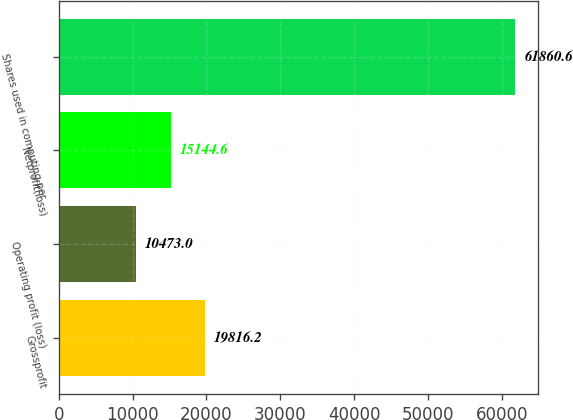<chart> <loc_0><loc_0><loc_500><loc_500><bar_chart><fcel>Grossprofit<fcel>Operating profit (loss)<fcel>Netprofit(loss)<fcel>Shares used in computing per<nl><fcel>19816.2<fcel>10473<fcel>15144.6<fcel>61860.6<nl></chart> 